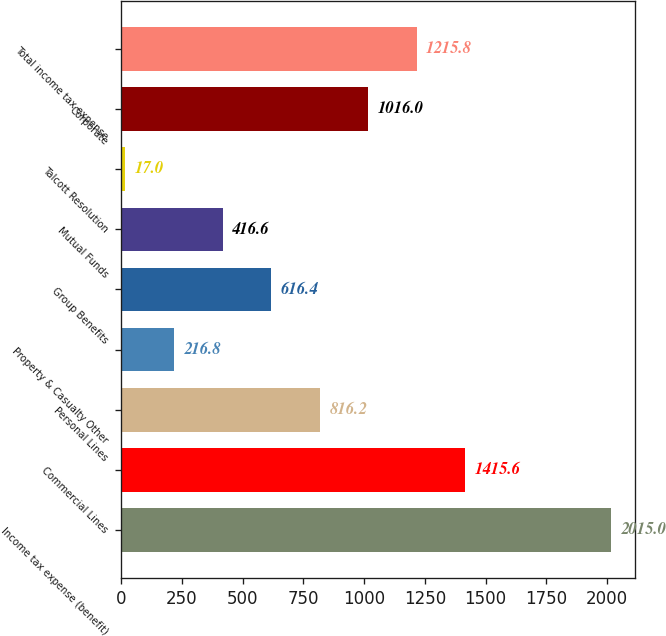Convert chart to OTSL. <chart><loc_0><loc_0><loc_500><loc_500><bar_chart><fcel>Income tax expense (benefit)<fcel>Commercial Lines<fcel>Personal Lines<fcel>Property & Casualty Other<fcel>Group Benefits<fcel>Mutual Funds<fcel>Talcott Resolution<fcel>Corporate<fcel>Total income tax expense<nl><fcel>2015<fcel>1415.6<fcel>816.2<fcel>216.8<fcel>616.4<fcel>416.6<fcel>17<fcel>1016<fcel>1215.8<nl></chart> 